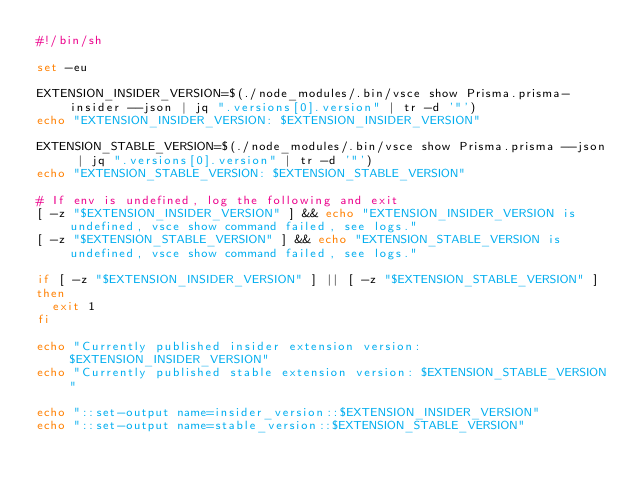<code> <loc_0><loc_0><loc_500><loc_500><_Bash_>#!/bin/sh

set -eu

EXTENSION_INSIDER_VERSION=$(./node_modules/.bin/vsce show Prisma.prisma-insider --json | jq ".versions[0].version" | tr -d '"')
echo "EXTENSION_INSIDER_VERSION: $EXTENSION_INSIDER_VERSION"

EXTENSION_STABLE_VERSION=$(./node_modules/.bin/vsce show Prisma.prisma --json | jq ".versions[0].version" | tr -d '"')
echo "EXTENSION_STABLE_VERSION: $EXTENSION_STABLE_VERSION"

# If env is undefined, log the following and exit
[ -z "$EXTENSION_INSIDER_VERSION" ] && echo "EXTENSION_INSIDER_VERSION is undefined, vsce show command failed, see logs."
[ -z "$EXTENSION_STABLE_VERSION" ] && echo "EXTENSION_STABLE_VERSION is undefined, vsce show command failed, see logs."

if [ -z "$EXTENSION_INSIDER_VERSION" ] || [ -z "$EXTENSION_STABLE_VERSION" ]
then
  exit 1
fi

echo "Currently published insider extension version: $EXTENSION_INSIDER_VERSION"
echo "Currently published stable extension version: $EXTENSION_STABLE_VERSION"

echo "::set-output name=insider_version::$EXTENSION_INSIDER_VERSION"
echo "::set-output name=stable_version::$EXTENSION_STABLE_VERSION"
</code> 